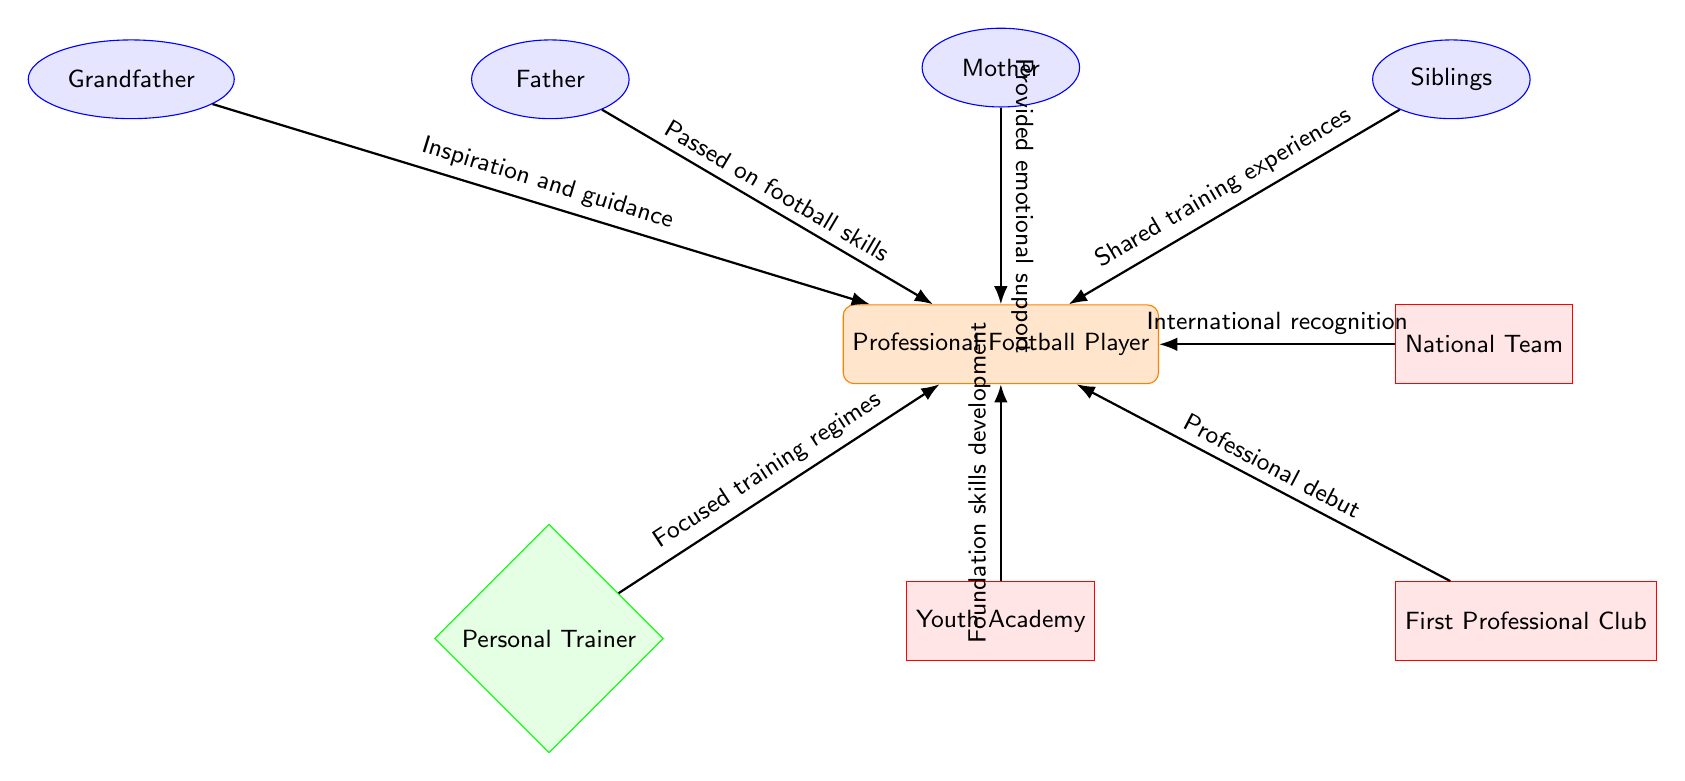What is the central node in the diagram? The central node in the diagram represents the "Professional Football Player" who is influenced by several factors around him, including family members and career steps.
Answer: Professional Football Player How many family members are depicted? The diagram shows four family members: Father, Mother, Siblings, and Grandfather. Therefore, by counting each family member node, the total is four.
Answer: 4 What does the arrow from the mother to the player represent? The arrow from the mother to the player indicates "Provided emotional support," which signifies how the mother's role impacts the football player's career.
Answer: Provided emotional support Which career step comes immediately after the Youth Academy? The career step that follows the Youth Academy is the First Professional Club, showing progression in the player’s career development.
Answer: First Professional Club What role does the Personal Trainer play in the player’s career? The Personal Trainer is indicated as a career influencer, with the contribution being "Focused training regimes," which emphasizes the trainer's role in enhancing the player's skills.
Answer: Focused training regimes How is the Grandfather connected to the player? The Grandfather is connected to the player through the relationship labeled "Inspiration and guidance," suggesting a motivational influence from the grandfather to the player.
Answer: Inspiration and guidance Which node indicates a step towards international recognition? The node that represents a step towards international recognition is the National Team, highlighting the player's opportunity at the international level.
Answer: National Team What type of relationship connects Siblings to the player? The relationship that links Siblings to the player is described as "Shared training experiences," suggesting a collaborative influence on skill development.
Answer: Shared training experiences What is the purpose of the Youth Academy in the player’s career progression? The Youth Academy serves the purpose of "Foundation skills development," which indicates its role in building the essential skills needed for a successful football career.
Answer: Foundation skills development 